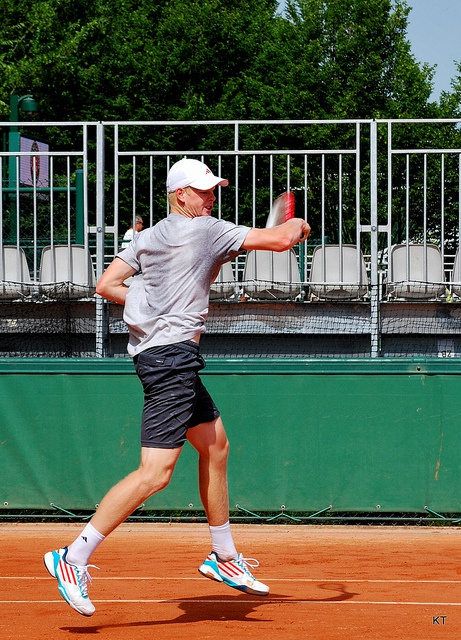Describe the objects in this image and their specific colors. I can see people in black, lavender, tan, and darkgray tones, chair in black, lightgray, darkgray, and gray tones, chair in black, lightgray, darkgray, and gray tones, chair in black, lightgray, darkgray, and gray tones, and chair in black, darkgray, lightgray, and gray tones in this image. 